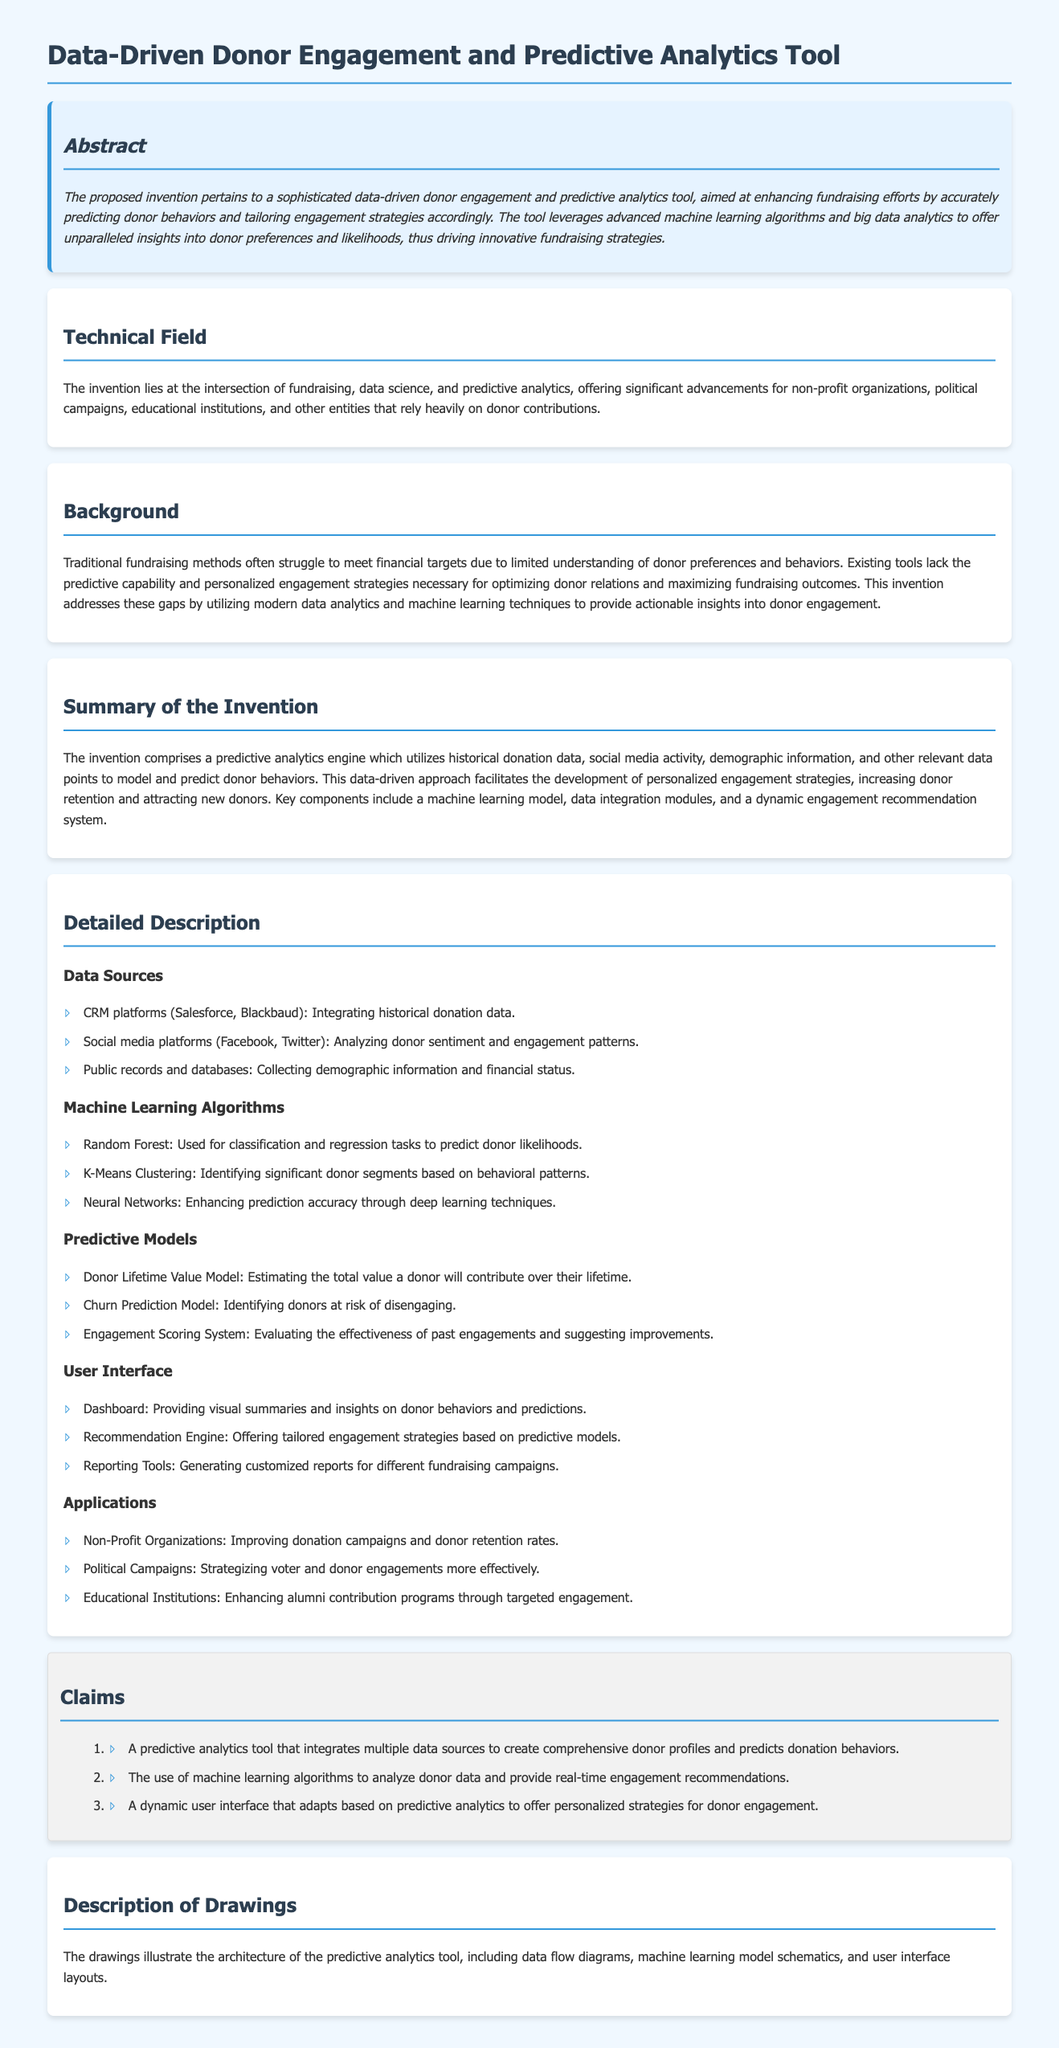What is the title of the invention? The title of the invention is stated at the beginning of the document.
Answer: Data-Driven Donor Engagement and Predictive Analytics Tool What is the primary purpose of the tool? The primary purpose of the tool is mentioned in the abstract section, focusing on enhancing fundraising efforts.
Answer: Enhancing fundraising efforts Which machine learning algorithm is used for classification tasks? The document specifies the algorithm used for classification tasks under machine learning algorithms.
Answer: Random Forest What is a key component of the predictive analytics engine? The summary of the invention lists key components, highlighting the predictive analytics engine's function.
Answer: Machine learning model Which organizations can benefit from the invention? The applications section identifies specific entities that can utilize the tool.
Answer: Non-Profit Organizations What type of model estimates donor lifetime value? The document details a specific predictive model in the predictive models section.
Answer: Donor Lifetime Value Model Which data source is used to analyze donor sentiment? The detailed description of data sources specifies where donor sentiment is analyzed.
Answer: Social media platforms What does the dynamic user interface provide? The user interface section outlines the functions offered by the dynamic interface.
Answer: Personalized strategies for donor engagement 